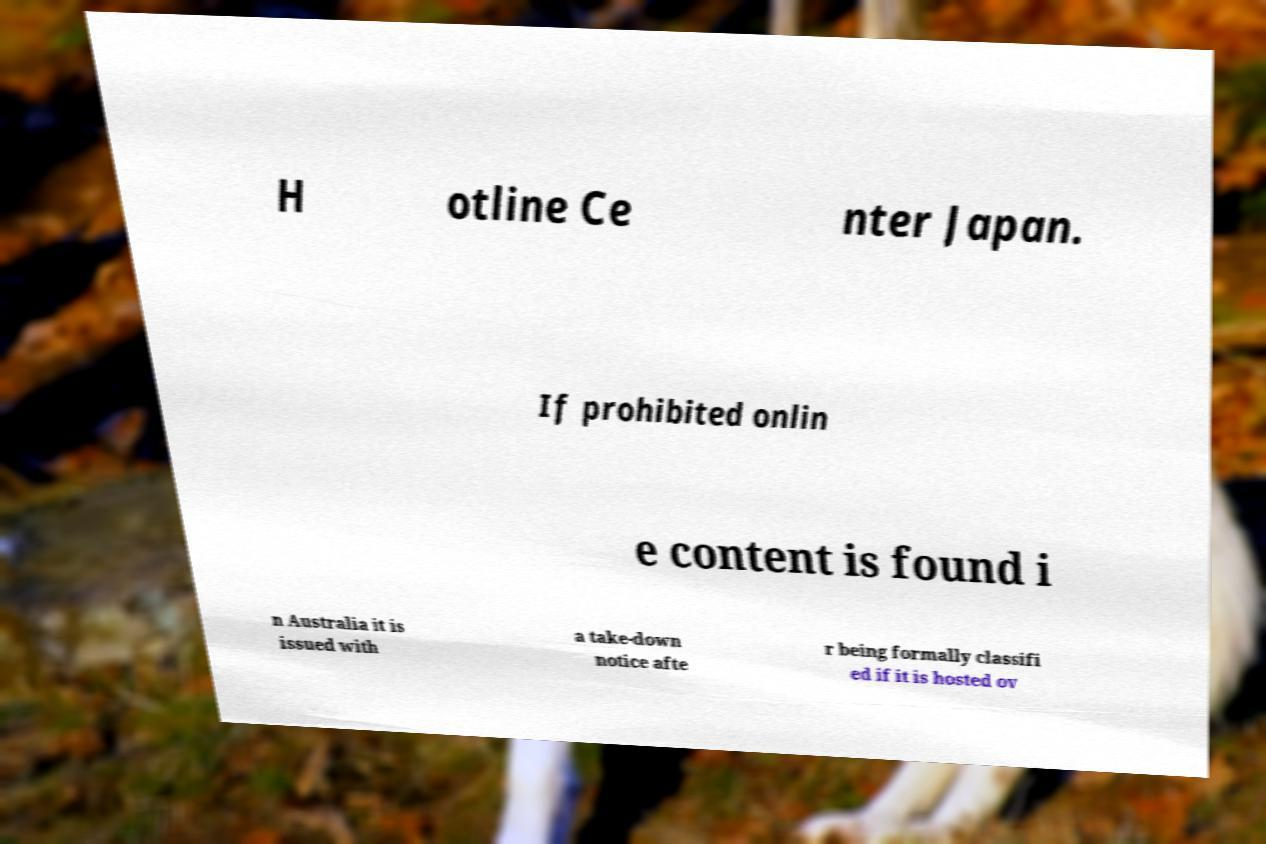For documentation purposes, I need the text within this image transcribed. Could you provide that? H otline Ce nter Japan. If prohibited onlin e content is found i n Australia it is issued with a take-down notice afte r being formally classifi ed if it is hosted ov 